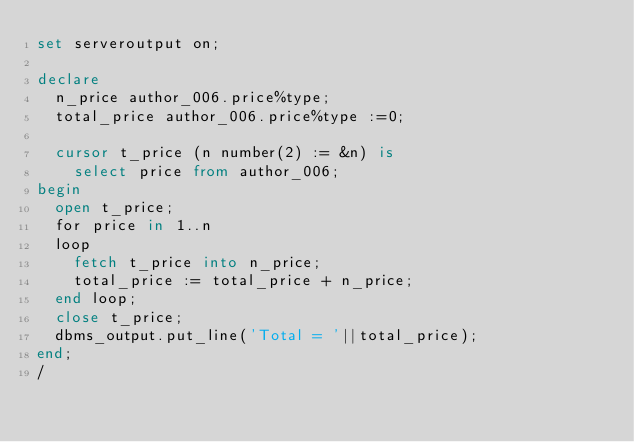<code> <loc_0><loc_0><loc_500><loc_500><_SQL_>set serveroutput on;

declare
	n_price author_006.price%type;
	total_price author_006.price%type :=0;

	cursor t_price (n number(2) := &n) is
		select price from author_006;
begin
	open t_price;
	for price in 1..n
	loop
		fetch t_price into n_price;
		total_price := total_price + n_price;
	end loop;
	close t_price;
	dbms_output.put_line('Total = '||total_price);
end;
/
</code> 